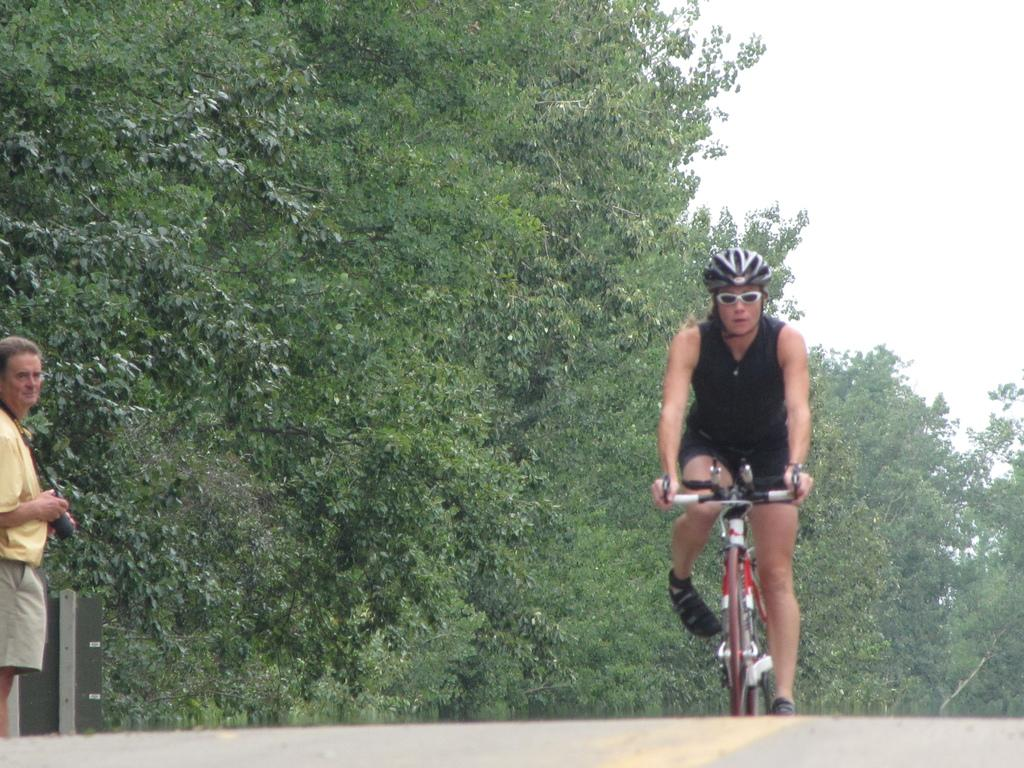What is the main subject of the image? There is a person riding a bicycle in the image. Where is the person riding the bicycle? The person is on the road. What can be seen on the left side of the image? There is a person holding a camera on the left side of the image. What is visible in the background of the image? There are trees and the sky visible in the background of the image. What type of linen is being used to balance the bicycle in the image? There is no linen present in the image, and the bicycle does not require any linen for balance. What word is being spelled out by the trees in the background of the image? The trees in the background of the image are not spelling out any words; they are simply trees. 